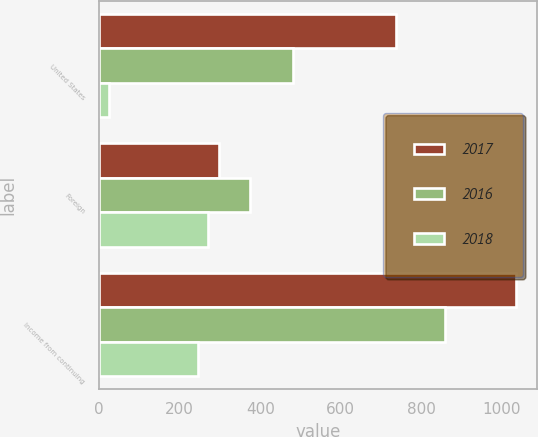Convert chart to OTSL. <chart><loc_0><loc_0><loc_500><loc_500><stacked_bar_chart><ecel><fcel>United States<fcel>Foreign<fcel>Income from continuing<nl><fcel>2017<fcel>736.7<fcel>298.1<fcel>1034.8<nl><fcel>2016<fcel>481.9<fcel>375.7<fcel>857.6<nl><fcel>2018<fcel>25.1<fcel>269.7<fcel>244.6<nl></chart> 